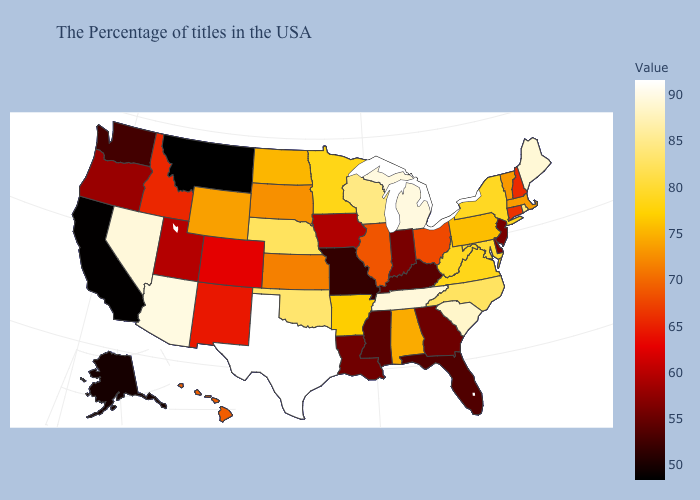Which states hav the highest value in the Northeast?
Give a very brief answer. Maine. Does Texas have the highest value in the USA?
Concise answer only. Yes. Among the states that border Pennsylvania , which have the highest value?
Concise answer only. Maryland. Is the legend a continuous bar?
Write a very short answer. Yes. Does Iowa have a higher value than Mississippi?
Quick response, please. Yes. Which states hav the highest value in the Northeast?
Give a very brief answer. Maine. Among the states that border South Dakota , does Montana have the lowest value?
Give a very brief answer. Yes. 